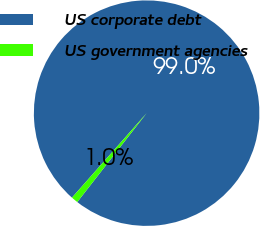<chart> <loc_0><loc_0><loc_500><loc_500><pie_chart><fcel>US corporate debt<fcel>US government agencies<nl><fcel>99.03%<fcel>0.97%<nl></chart> 